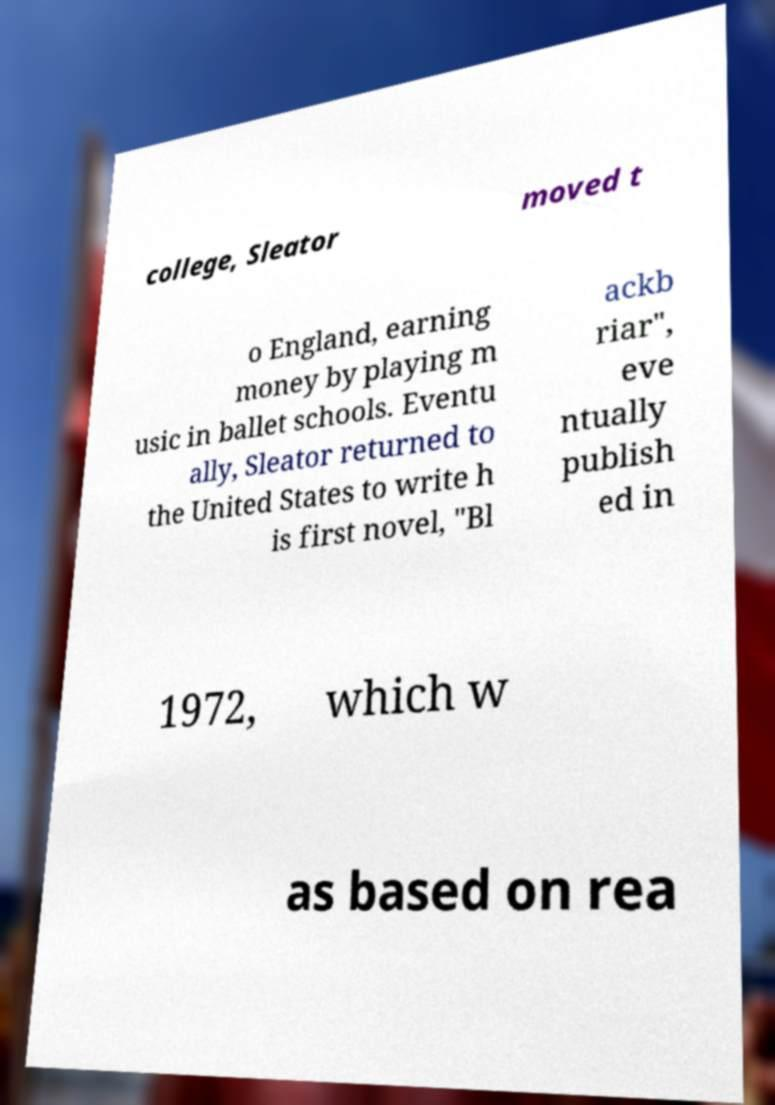For documentation purposes, I need the text within this image transcribed. Could you provide that? college, Sleator moved t o England, earning money by playing m usic in ballet schools. Eventu ally, Sleator returned to the United States to write h is first novel, "Bl ackb riar", eve ntually publish ed in 1972, which w as based on rea 